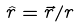<formula> <loc_0><loc_0><loc_500><loc_500>\hat { r } = \vec { r } / r</formula> 